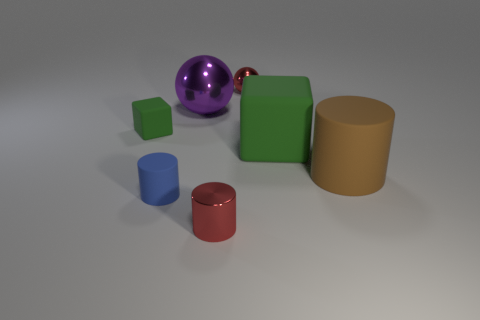Is the small shiny cylinder the same color as the tiny metal ball?
Offer a very short reply. Yes. What number of red cylinders have the same material as the tiny red ball?
Offer a very short reply. 1. There is a tiny red thing that is in front of the brown matte cylinder; what shape is it?
Your response must be concise. Cylinder. Does the small cylinder that is to the right of the purple metallic sphere have the same material as the green block that is on the right side of the tiny blue matte thing?
Make the answer very short. No. Is there another metallic thing of the same shape as the tiny blue object?
Offer a very short reply. Yes. How many objects are either green objects to the right of the large metal sphere or big red metallic cylinders?
Your answer should be compact. 1. Is the number of tiny blue rubber objects that are on the left side of the big shiny thing greater than the number of small metal balls that are on the right side of the small sphere?
Make the answer very short. Yes. How many rubber things are either large yellow spheres or small red cylinders?
Provide a short and direct response. 0. There is a thing that is the same color as the large rubber cube; what material is it?
Your answer should be very brief. Rubber. Is the number of green matte things that are behind the tiny block less than the number of green things that are on the left side of the purple shiny ball?
Keep it short and to the point. Yes. 